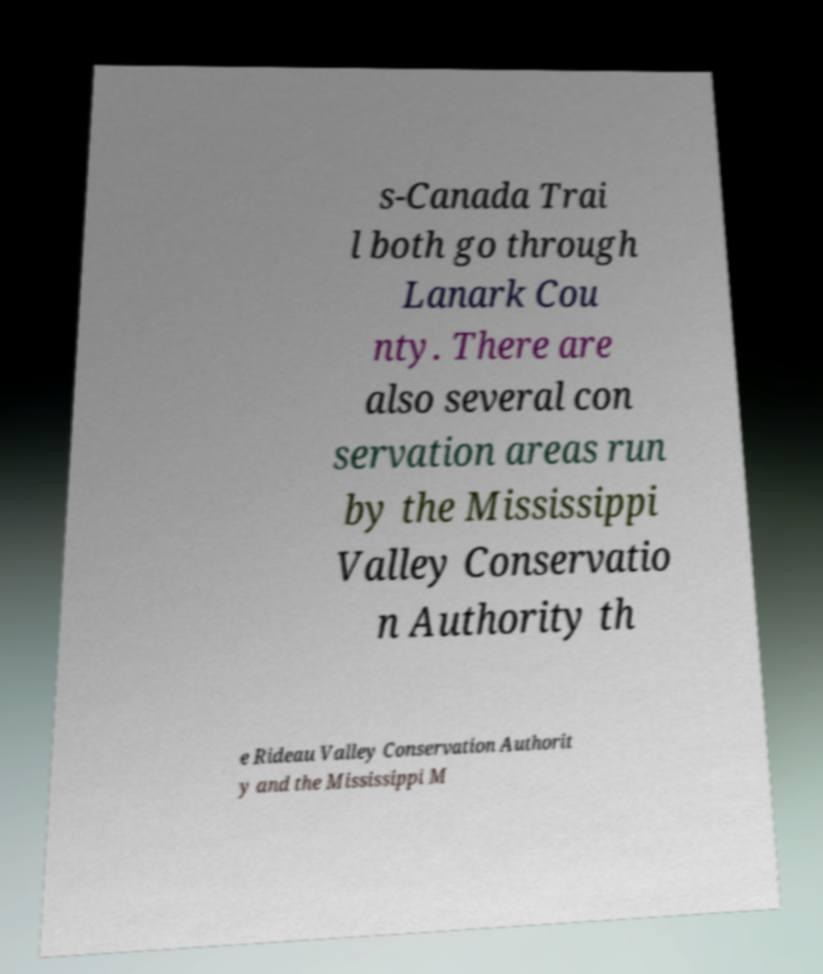Can you accurately transcribe the text from the provided image for me? s-Canada Trai l both go through Lanark Cou nty. There are also several con servation areas run by the Mississippi Valley Conservatio n Authority th e Rideau Valley Conservation Authorit y and the Mississippi M 